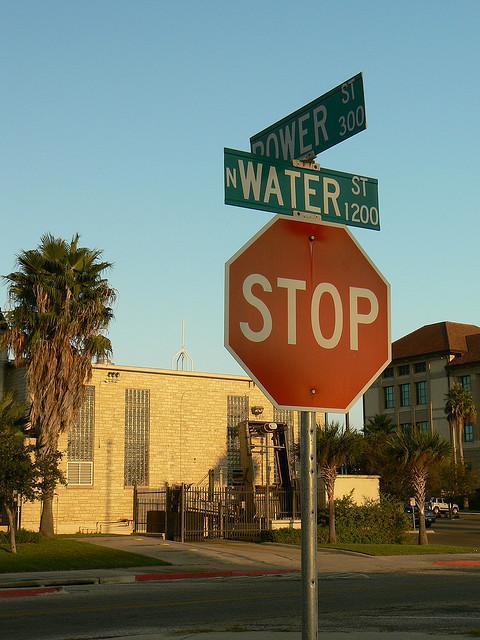How many green signs are there?
Give a very brief answer. 2. 